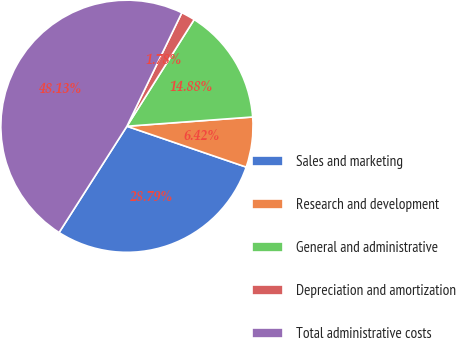<chart> <loc_0><loc_0><loc_500><loc_500><pie_chart><fcel>Sales and marketing<fcel>Research and development<fcel>General and administrative<fcel>Depreciation and amortization<fcel>Total administrative costs<nl><fcel>28.79%<fcel>6.42%<fcel>14.88%<fcel>1.78%<fcel>48.13%<nl></chart> 